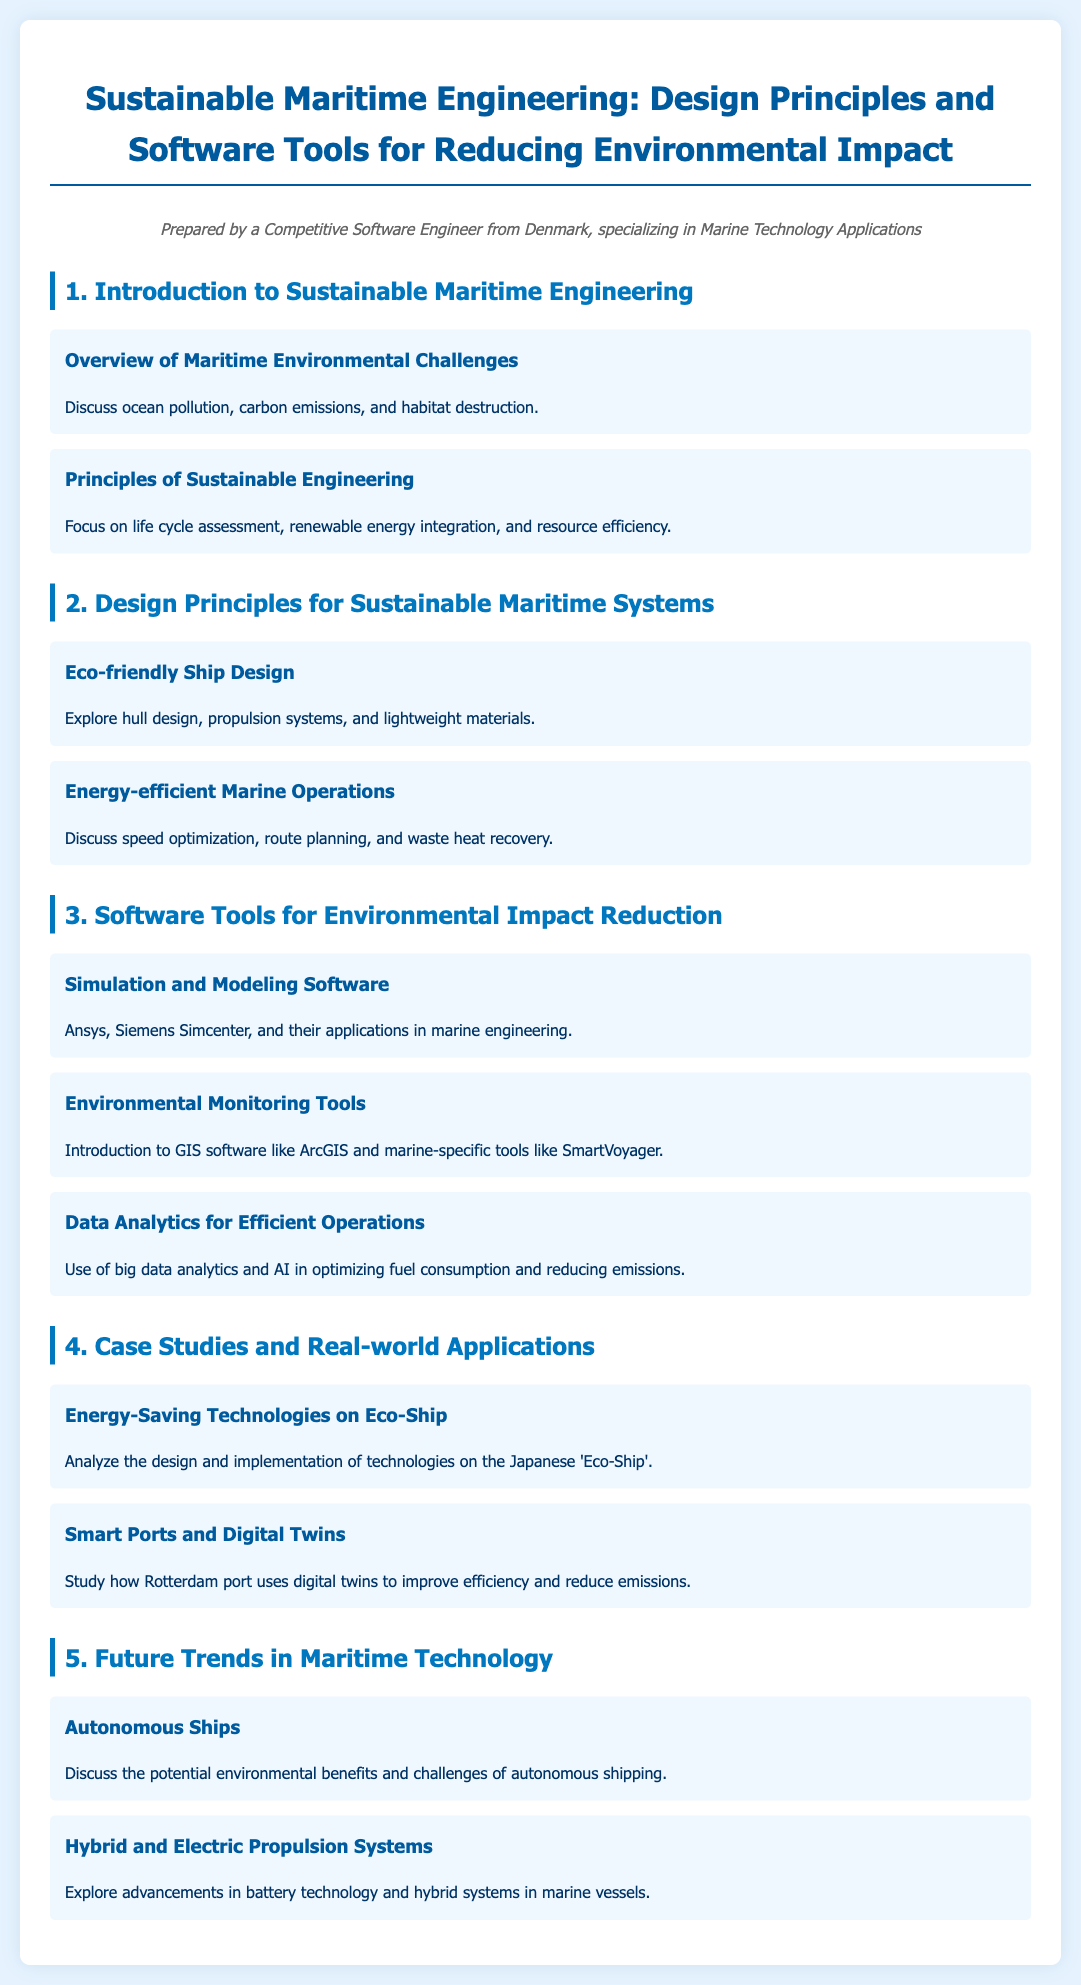what are the main challenges discussed in the syllabus? The main challenges discussed include ocean pollution, carbon emissions, and habitat destruction.
Answer: ocean pollution, carbon emissions, habitat destruction what principle focuses on renewable energy integration? The principle that focuses on renewable energy integration is part of Sustainable Engineering.
Answer: Sustainable Engineering which software tools are mentioned for simulation in marine engineering? The software tools mentioned for simulation in marine engineering include Ansys and Siemens Simcenter.
Answer: Ansys, Siemens Simcenter what type of propulsion systems are explored in the syllabus? The syllabus explores hybrid and electric propulsion systems.
Answer: hybrid and electric propulsion systems how is Rotterdam port improving efficiency? Rotterdam port is improving efficiency through the use of digital twins.
Answer: digital twins what is a key benefit of autonomous shipping mentioned? A key benefit of autonomous shipping mentioned is its potential environmental benefits.
Answer: environmental benefits what technology was analyzed in the case study about Eco-Ship? The analyzed technology in the case study about Eco-Ship includes energy-saving technologies.
Answer: energy-saving technologies which GIS software is introduced for environmental monitoring? The GIS software introduced for environmental monitoring is ArcGIS.
Answer: ArcGIS what is the focus of data analytics discussed in the syllabus? The focus of data analytics discussed is on optimizing fuel consumption and reducing emissions.
Answer: optimizing fuel consumption and reducing emissions 